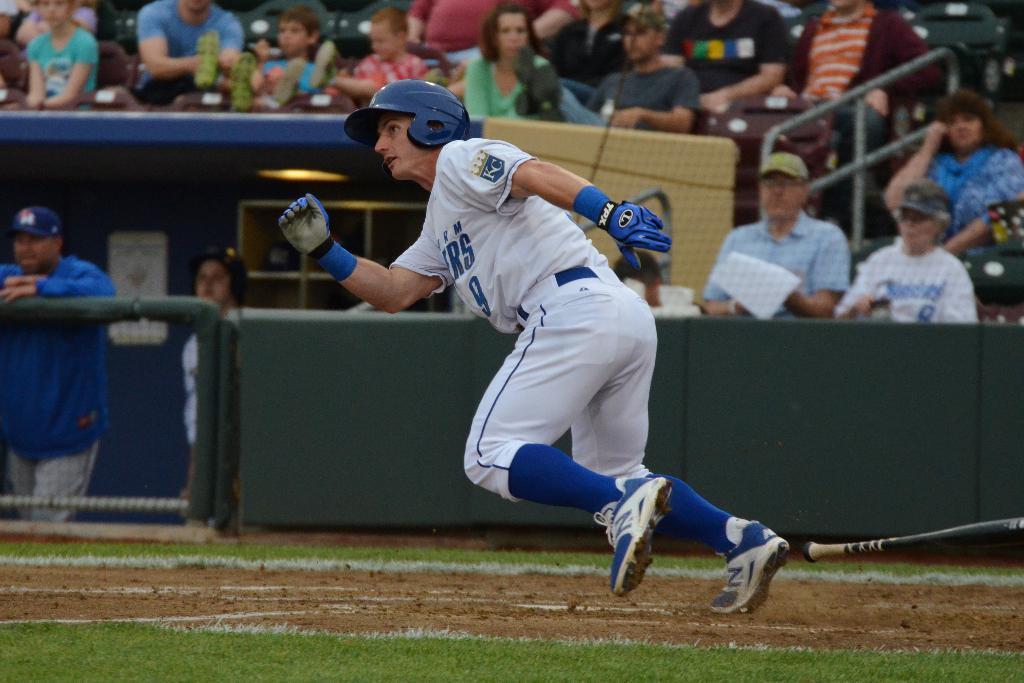How would you summarize this image in a sentence or two? In the picture I can see a person wearing white dress is running and there is a base ball bat in the right corner and there are few audience in the background. 